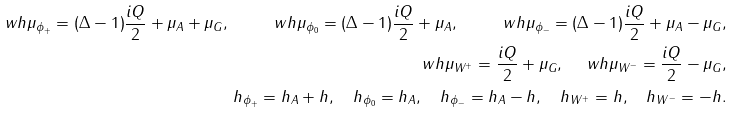Convert formula to latex. <formula><loc_0><loc_0><loc_500><loc_500>\ w h \mu _ { \phi _ { + } } = ( \Delta - 1 ) \frac { i Q } { 2 } + \mu _ { A } + \mu _ { G } , \quad \ w h \mu _ { \phi _ { 0 } } = ( \Delta - 1 ) \frac { i Q } { 2 } + \mu _ { A } , \quad \ w h \mu _ { \phi _ { - } } = ( \Delta - 1 ) \frac { i Q } { 2 } + \mu _ { A } - \mu _ { G } , \\ \ w h \mu _ { W ^ { + } } = \frac { i Q } { 2 } + \mu _ { G } , \quad \ w h \mu _ { W ^ { - } } = \frac { i Q } { 2 } - \mu _ { G } , \\ h _ { \phi _ { + } } = h _ { A } + h , \quad h _ { \phi _ { 0 } } = h _ { A } , \quad h _ { \phi _ { - } } = h _ { A } - h , \quad h _ { W ^ { + } } = h , \quad h _ { W ^ { - } } = - h .</formula> 